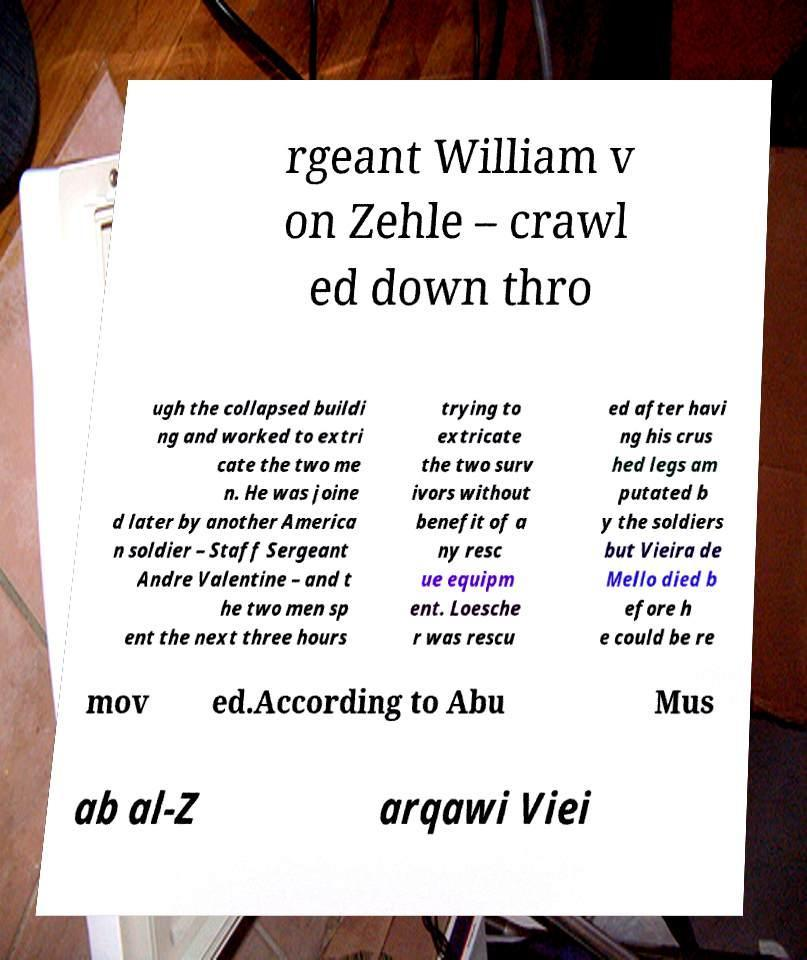For documentation purposes, I need the text within this image transcribed. Could you provide that? rgeant William v on Zehle – crawl ed down thro ugh the collapsed buildi ng and worked to extri cate the two me n. He was joine d later by another America n soldier – Staff Sergeant Andre Valentine – and t he two men sp ent the next three hours trying to extricate the two surv ivors without benefit of a ny resc ue equipm ent. Loesche r was rescu ed after havi ng his crus hed legs am putated b y the soldiers but Vieira de Mello died b efore h e could be re mov ed.According to Abu Mus ab al-Z arqawi Viei 